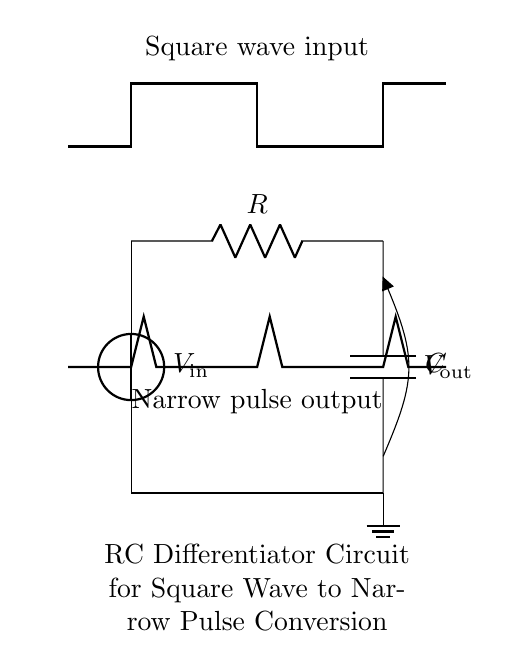What is the type of input waveform shown? The circuit diagram depicts a square wave input, characterized by periodic high and low voltage levels. This is identified by the sharp transitions in the input waveform that rise and fall abruptly.
Answer: Square wave What component is responsible for shaping the output pulse? The capacitor in the circuit plays a crucial role in shaping the output pulse; it charges and discharges, influencing the output waveform characteristics in response to the input signal.
Answer: Capacitor What is the function of the resistor in this circuit? The resistor affects the time constant of the circuit, which determines how quickly the capacitor can charge and discharge. This time constant is critical for defining the output pulse width.
Answer: Time constant What is the expected output voltage behavior when the input transitions from low to high? When the input voltage rapidly transitions from low to high, the capacitor initially allows a brief surge of current, producing a spike in the output voltage. This is due to the momentary charging action of the capacitor, resulting in a narrow pulse at the output.
Answer: Narrow pulse What does the time constant determine in an RC differentiator circuit? The time constant, defined by the product of the resistance and capacitance values (R*C), dictates the rate at which the capacitor charges and discharges. It directly influences the width of the output pulse created in response to the input square wave.
Answer: Pulse width What is the role of the ground in this circuit? The ground serves as a reference point for the circuit's voltage levels, ensuring a common return path for the electrical current and stabilizing the operation of the components involved.
Answer: Reference point 